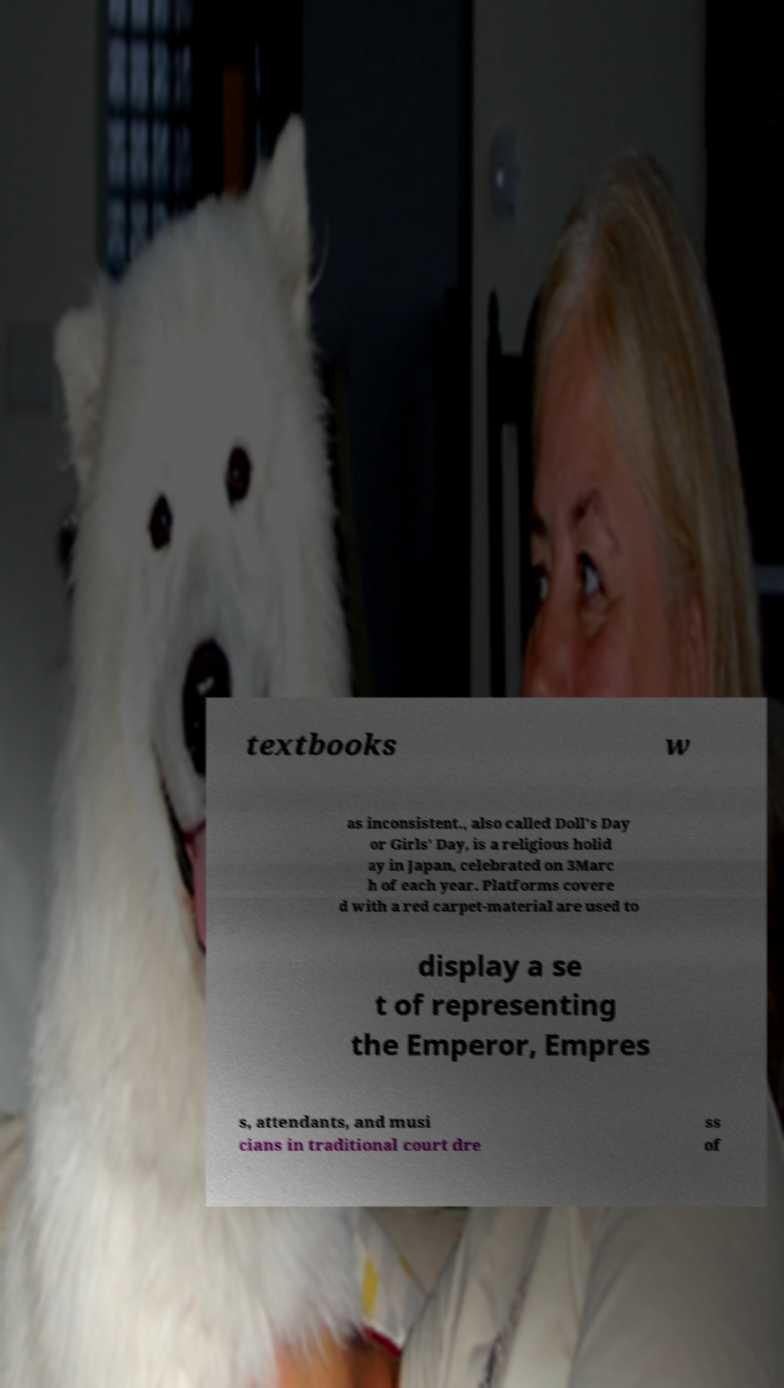Please read and relay the text visible in this image. What does it say? textbooks w as inconsistent., also called Doll's Day or Girls' Day, is a religious holid ay in Japan, celebrated on 3Marc h of each year. Platforms covere d with a red carpet-material are used to display a se t of representing the Emperor, Empres s, attendants, and musi cians in traditional court dre ss of 